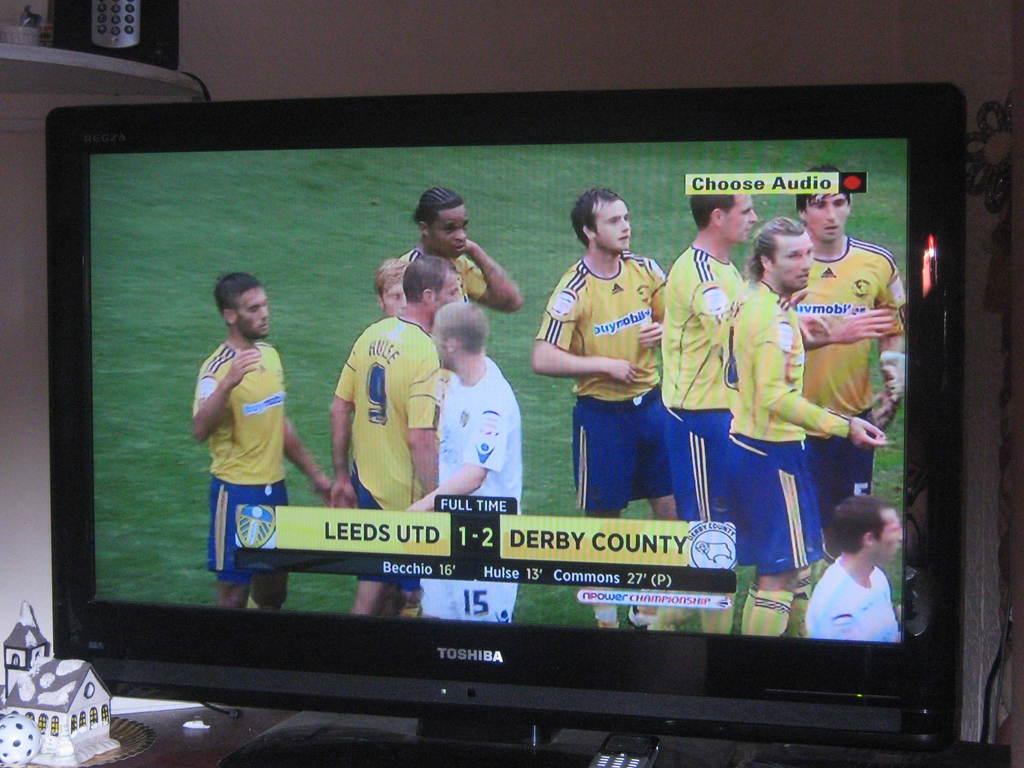What team is leeds playing against?
Ensure brevity in your answer.  Derby county. What was the final score of this game?
Provide a short and direct response. 1-2. 